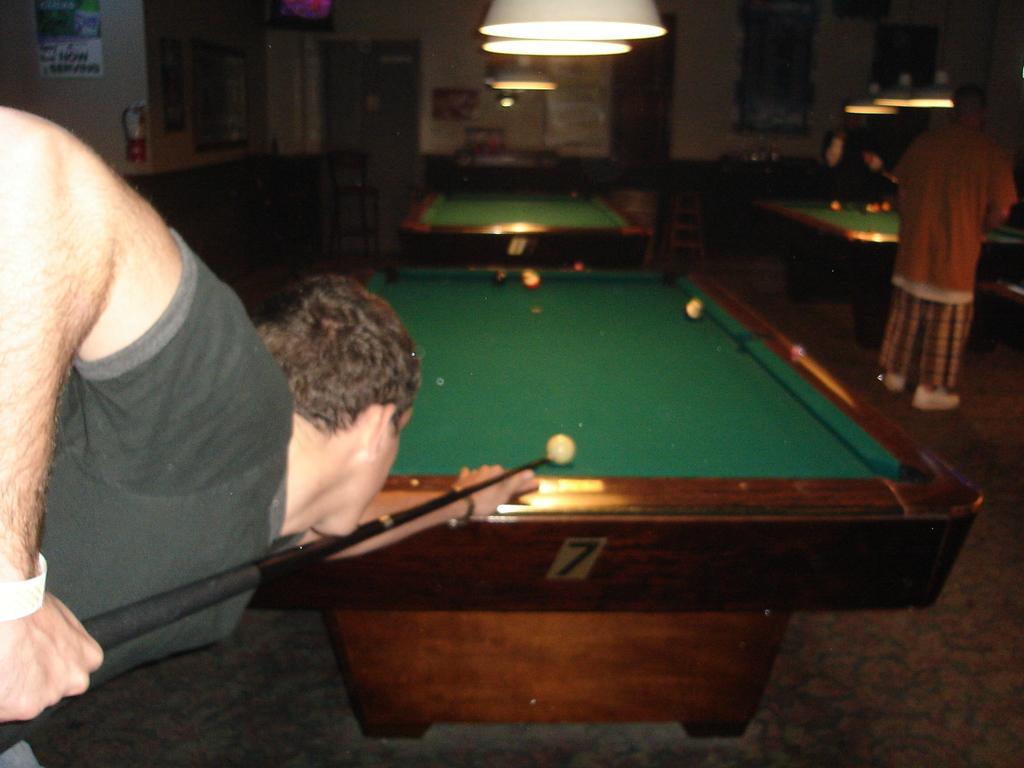In one or two sentences, can you explain what this image depicts? In this image a man is playing a snooker game. In the background there are two tables of snooker. At the right side two men are standing. There is a light hanging. 